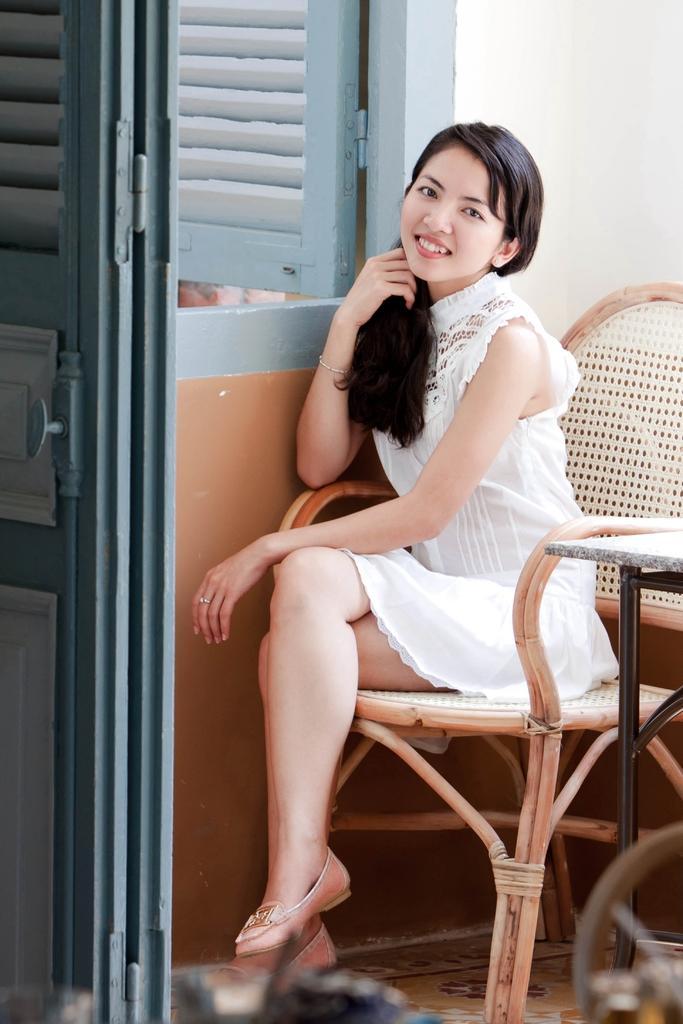Can you describe this image briefly? Girl sitting on the chair near the door and table. 